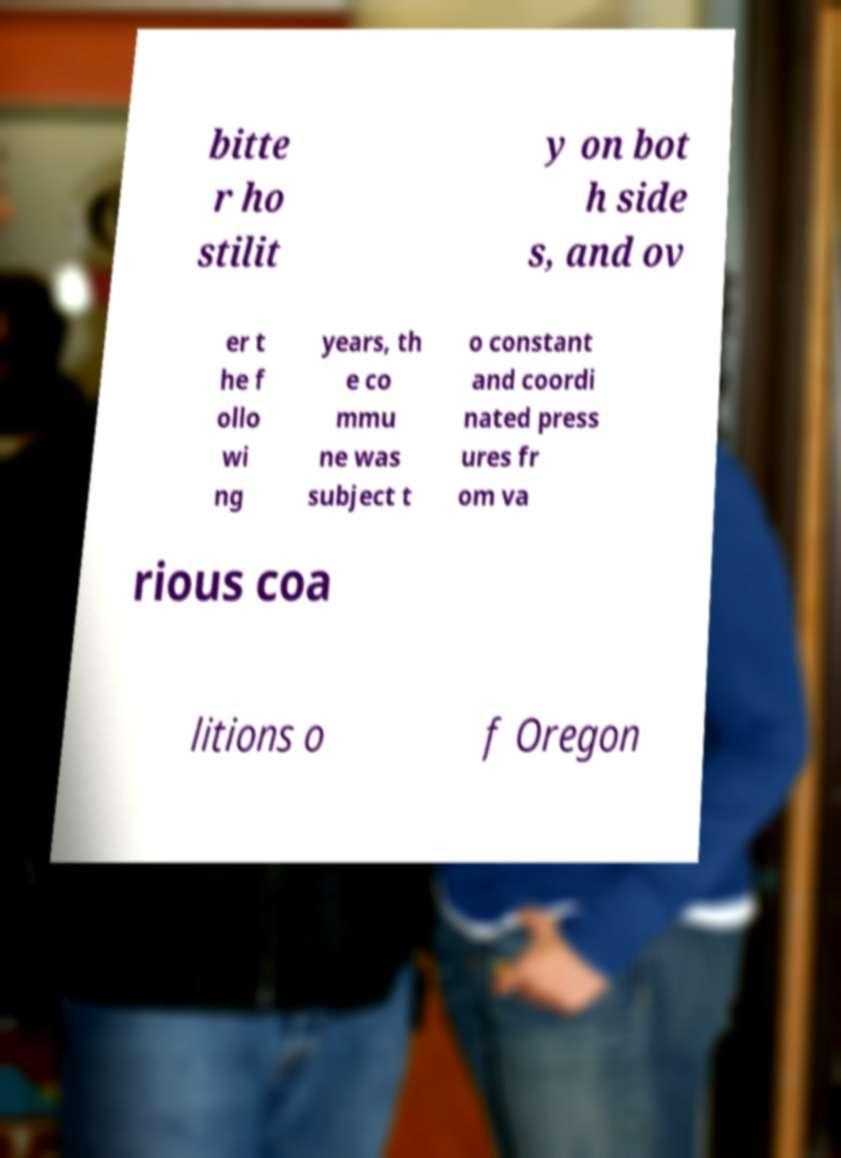Please read and relay the text visible in this image. What does it say? bitte r ho stilit y on bot h side s, and ov er t he f ollo wi ng years, th e co mmu ne was subject t o constant and coordi nated press ures fr om va rious coa litions o f Oregon 